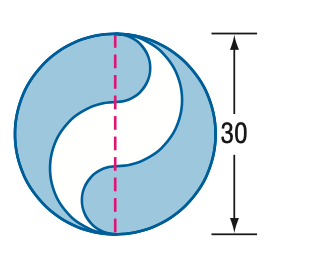Find the area of the shaded region. Round to the nearest tenth. The area of the shaded region, option B, is 471.2 square units. When calculating areas involving circles or sections of circles, you'd typically use the formula for the area of a circle (A = πr²) and make necessary adjustments for the given segments. Given that this figure presents a unique shape, the calculation likely involves subtracting areas of segments from the area of the whole circle, based on the diameter provided. The answer provided is in line with the standard mathematical procedures for such calculations, assuming the unshaded portions represent common geometric shapes such as semicircles or quarter circles. 